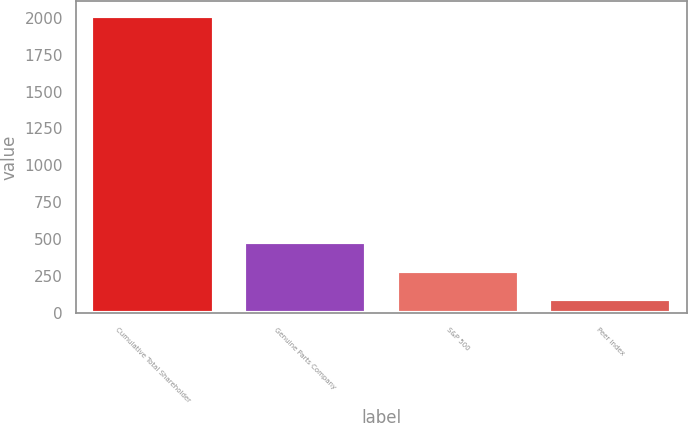Convert chart. <chart><loc_0><loc_0><loc_500><loc_500><bar_chart><fcel>Cumulative Total Shareholder<fcel>Genuine Parts Company<fcel>S&P 500<fcel>Peer Index<nl><fcel>2011<fcel>478.73<fcel>287.2<fcel>95.67<nl></chart> 